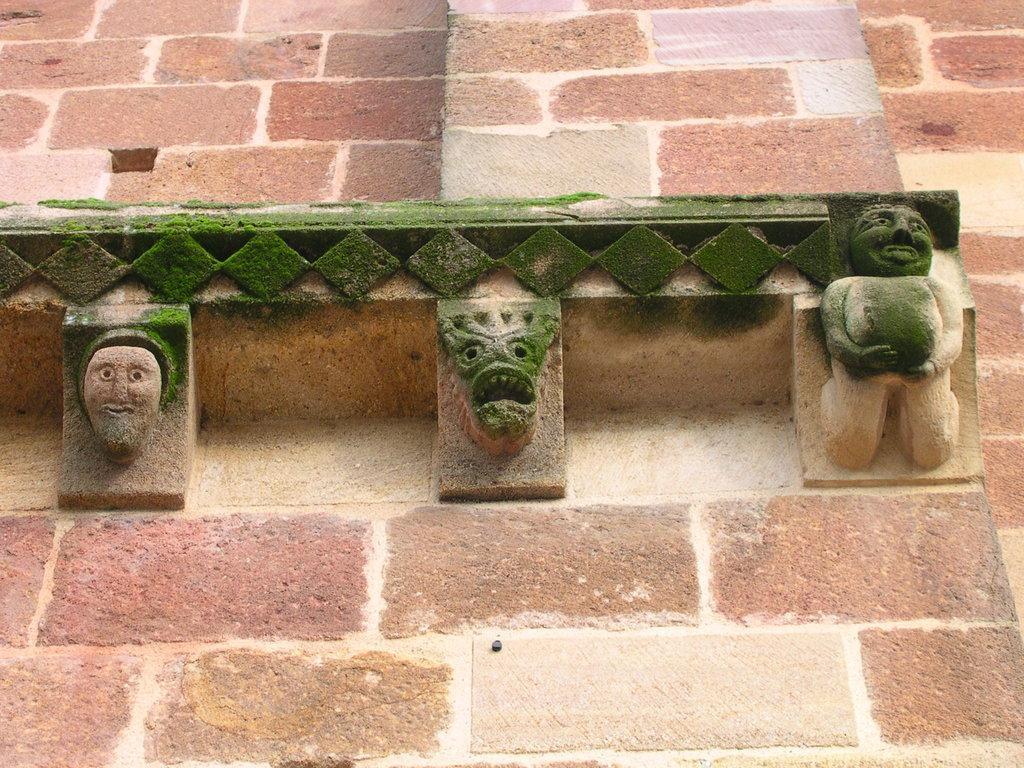In one or two sentences, can you explain what this image depicts? In this image, we can see some sculptures on the wall. 